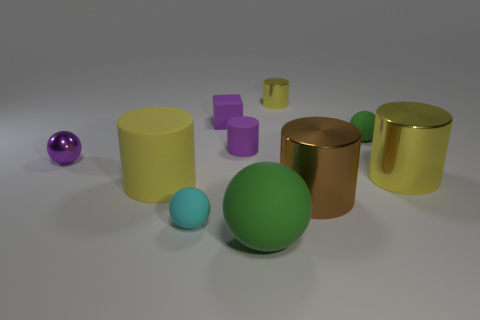There is a tiny ball that is in front of the yellow shiny object to the right of the small metal cylinder; what is it made of?
Your response must be concise. Rubber. How many big green rubber objects have the same shape as the big brown metallic object?
Ensure brevity in your answer.  0. What size is the yellow object on the left side of the big matte object in front of the yellow cylinder left of the small purple matte cube?
Your answer should be compact. Large. How many green things are either small spheres or small rubber balls?
Offer a very short reply. 1. Does the large object on the left side of the cyan sphere have the same shape as the small cyan object?
Ensure brevity in your answer.  No. Are there more brown metallic cylinders in front of the brown shiny cylinder than big blue balls?
Ensure brevity in your answer.  No. What number of purple metallic balls have the same size as the purple metal object?
Make the answer very short. 0. What is the size of the cylinder that is the same color as the metallic sphere?
Provide a succinct answer. Small. What number of things are either tiny metallic balls or metallic cylinders behind the big brown metallic object?
Ensure brevity in your answer.  3. There is a matte sphere that is in front of the purple matte cylinder and right of the small cyan matte ball; what is its color?
Make the answer very short. Green. 